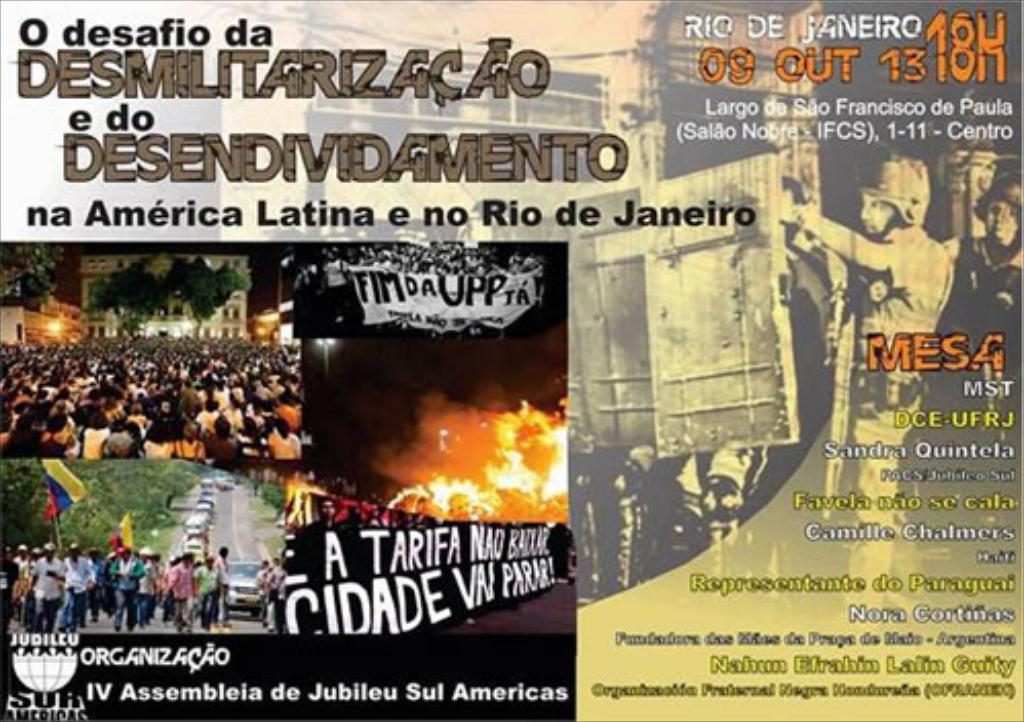What details in the image give us hints about the time and location of these protests? The image includes specifics like 'RIO DE JANEIRO,' a date '09 OUT' (October 9th), and a time '13H' (1 PM). The location 'Largo do Sao Francisco de Paula (IFCS) 1-11 - Centro' is indicated, providing precise information about where and when these events either occurred or were scheduled. 